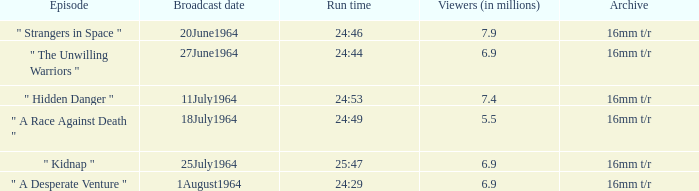What episode aired on 11july1964? " Hidden Danger ". 